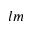Convert formula to latex. <formula><loc_0><loc_0><loc_500><loc_500>l m</formula> 